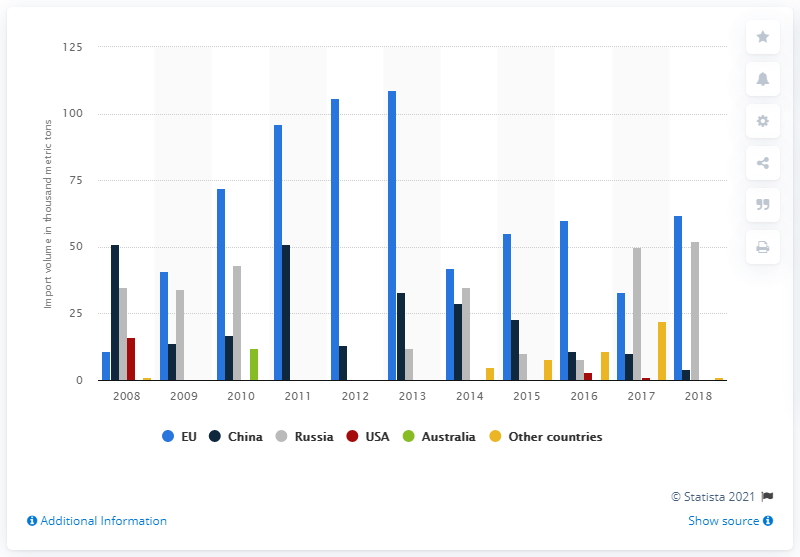Draw attention to some important aspects in this diagram. In 2017, Russia was the primary exporter of anthracite coal. 